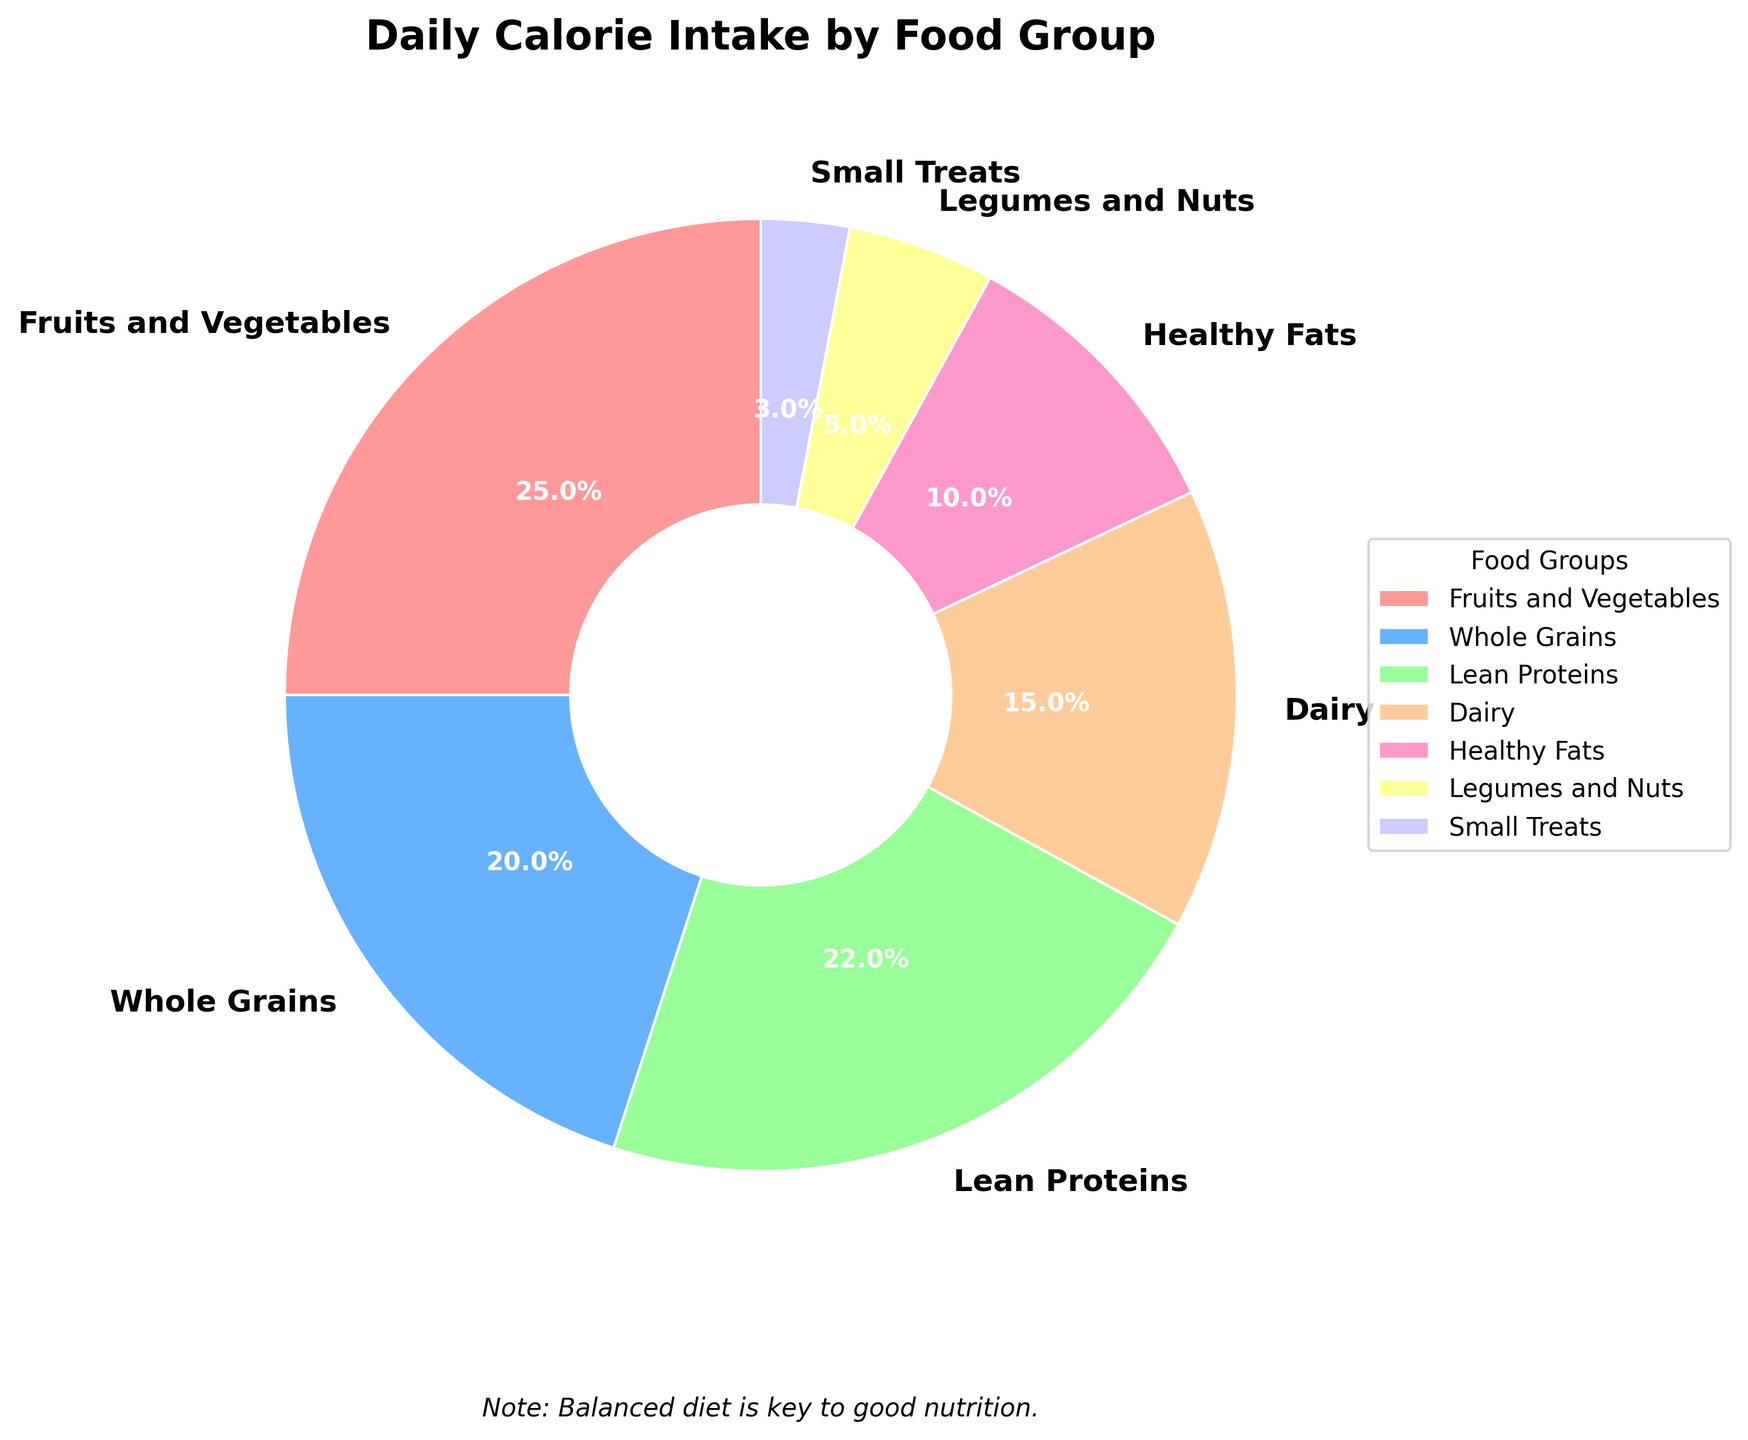What is the food group with the highest percentage of daily calorie intake? According to the pie chart, the food group with the highest percentage is listed as Fruits and Vegetables, which makes up 25% of daily calorie intake.
Answer: Fruits and Vegetables Which has a higher percentage of daily calorie intake: Lean Proteins or Whole Grains? From the chart, Lean Proteins contribute 22%, and Whole Grains contribute 20% to the daily calorie intake. Lean Proteins have a higher percentage.
Answer: Lean Proteins What is the sum of the percentages for Dairy and Healthy Fats? According to the pie chart, Dairy makes up 15% and Healthy Fats make up 10%. Summing these, 15% + 10% = 25%.
Answer: 25% By how much do Lean Proteins exceed Legumes and Nuts in percentage? The chart shows that Lean Proteins account for 22% and Legumes and Nuts for 5%. The difference is 22% - 5% = 17%.
Answer: 17% Which food groups combined give a total of 45% of daily calorie intake? According to the pie chart, combining Dairy (15%), Healthy Fats (10%), and Whole Grains (20%) sums up to 15% + 10% + 20% = 45%.
Answer: Dairy, Healthy Fats, Whole Grains Are there any food groups that contribute less than 10% to the daily calorie intake? The chart indicates that the categories comprising less than 10% are Legumes and Nuts (5%) and Small Treats (3%).
Answer: Yes What percentage of the daily calorie intake comes from food groups other than Fruits and Vegetables? From the pie chart, the total is 100%, and Fruits and Vegetables make up 25%. Therefore, the percentage from other food groups is 100% - 25% = 75%.
Answer: 75% If Dairy and Whole Grains are combined, does their percentage exceed that of Fruits and Vegetables? From the chart, Dairy is 15% and Whole Grains are 20%. Combined, they total 15% + 20% = 35%, which exceeds Fruits and Vegetables' 25%.
Answer: Yes Which food group is represented in pink color in the pie chart? By evaluating the visual representation, the food group Fruits and Vegetables is depicted in pink color.
Answer: Fruits and Vegetables 